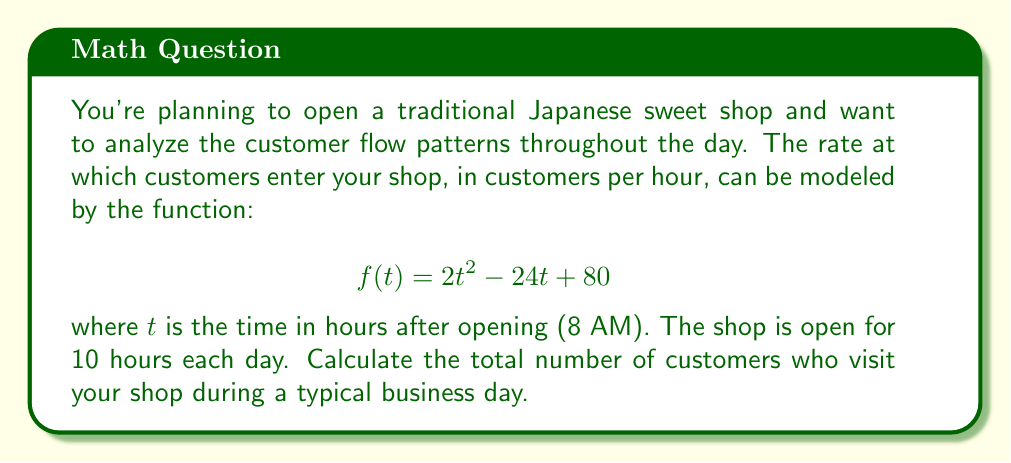Give your solution to this math problem. To solve this problem, we need to use integral calculus to find the area under the curve of the given function over the specified time period. This area represents the total number of customers visiting the shop during the day.

1. Set up the definite integral:
   The shop is open for 10 hours, so we integrate from $t=0$ to $t=10$.
   $$\int_0^{10} (2t^2 - 24t + 80) dt$$

2. Integrate the function:
   $$\int (2t^2 - 24t + 80) dt = \frac{2t^3}{3} - 12t^2 + 80t + C$$

3. Apply the limits of integration:
   $$\left[\frac{2t^3}{3} - 12t^2 + 80t\right]_0^{10}$$

4. Calculate the result:
   $$\left(\frac{2(10)^3}{3} - 12(10)^2 + 80(10)\right) - \left(\frac{2(0)^3}{3} - 12(0)^2 + 80(0)\right)$$
   $$= \left(\frac{2000}{3} - 1200 + 800\right) - (0)$$
   $$= \frac{2000}{3} - 400$$
   $$= \frac{2000 - 1200}{3}$$
   $$= \frac{800}{3}$$
   $$\approx 266.67$$

5. Since we can't have a fractional number of customers, we round to the nearest whole number.
Answer: 267 customers 